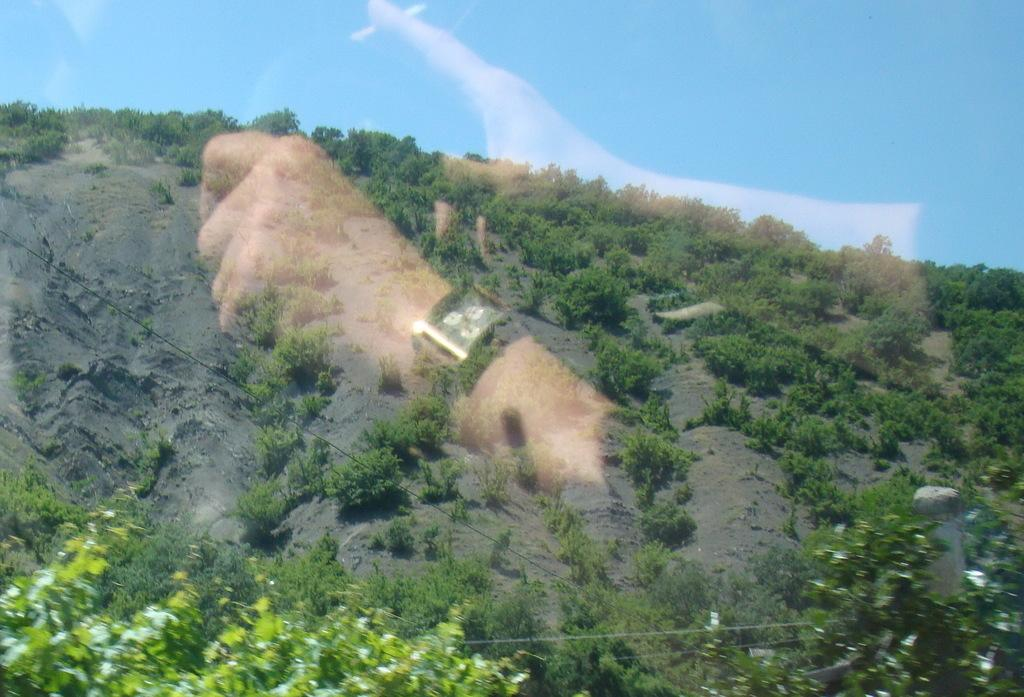What is the person in the image doing? There is a person sitting in the image, and they are holding a cigar in their right hand. What can be seen in the background of the image? There is a mountain and trees in the image. What is the condition of the sky in the image? The sky is clear in the image. What type of cub can be seen playing with a piece of coal in the image? There is no cub or coal present in the image. Is the person wearing a shoe in the image? The provided facts do not mention anything about shoes, so we cannot determine if the person is wearing a shoe in the image. 